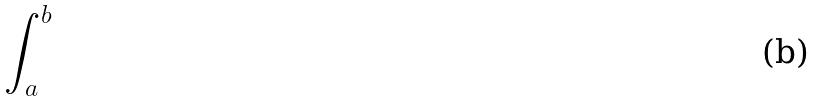Convert formula to latex. <formula><loc_0><loc_0><loc_500><loc_500>\int _ { a } ^ { b }</formula> 